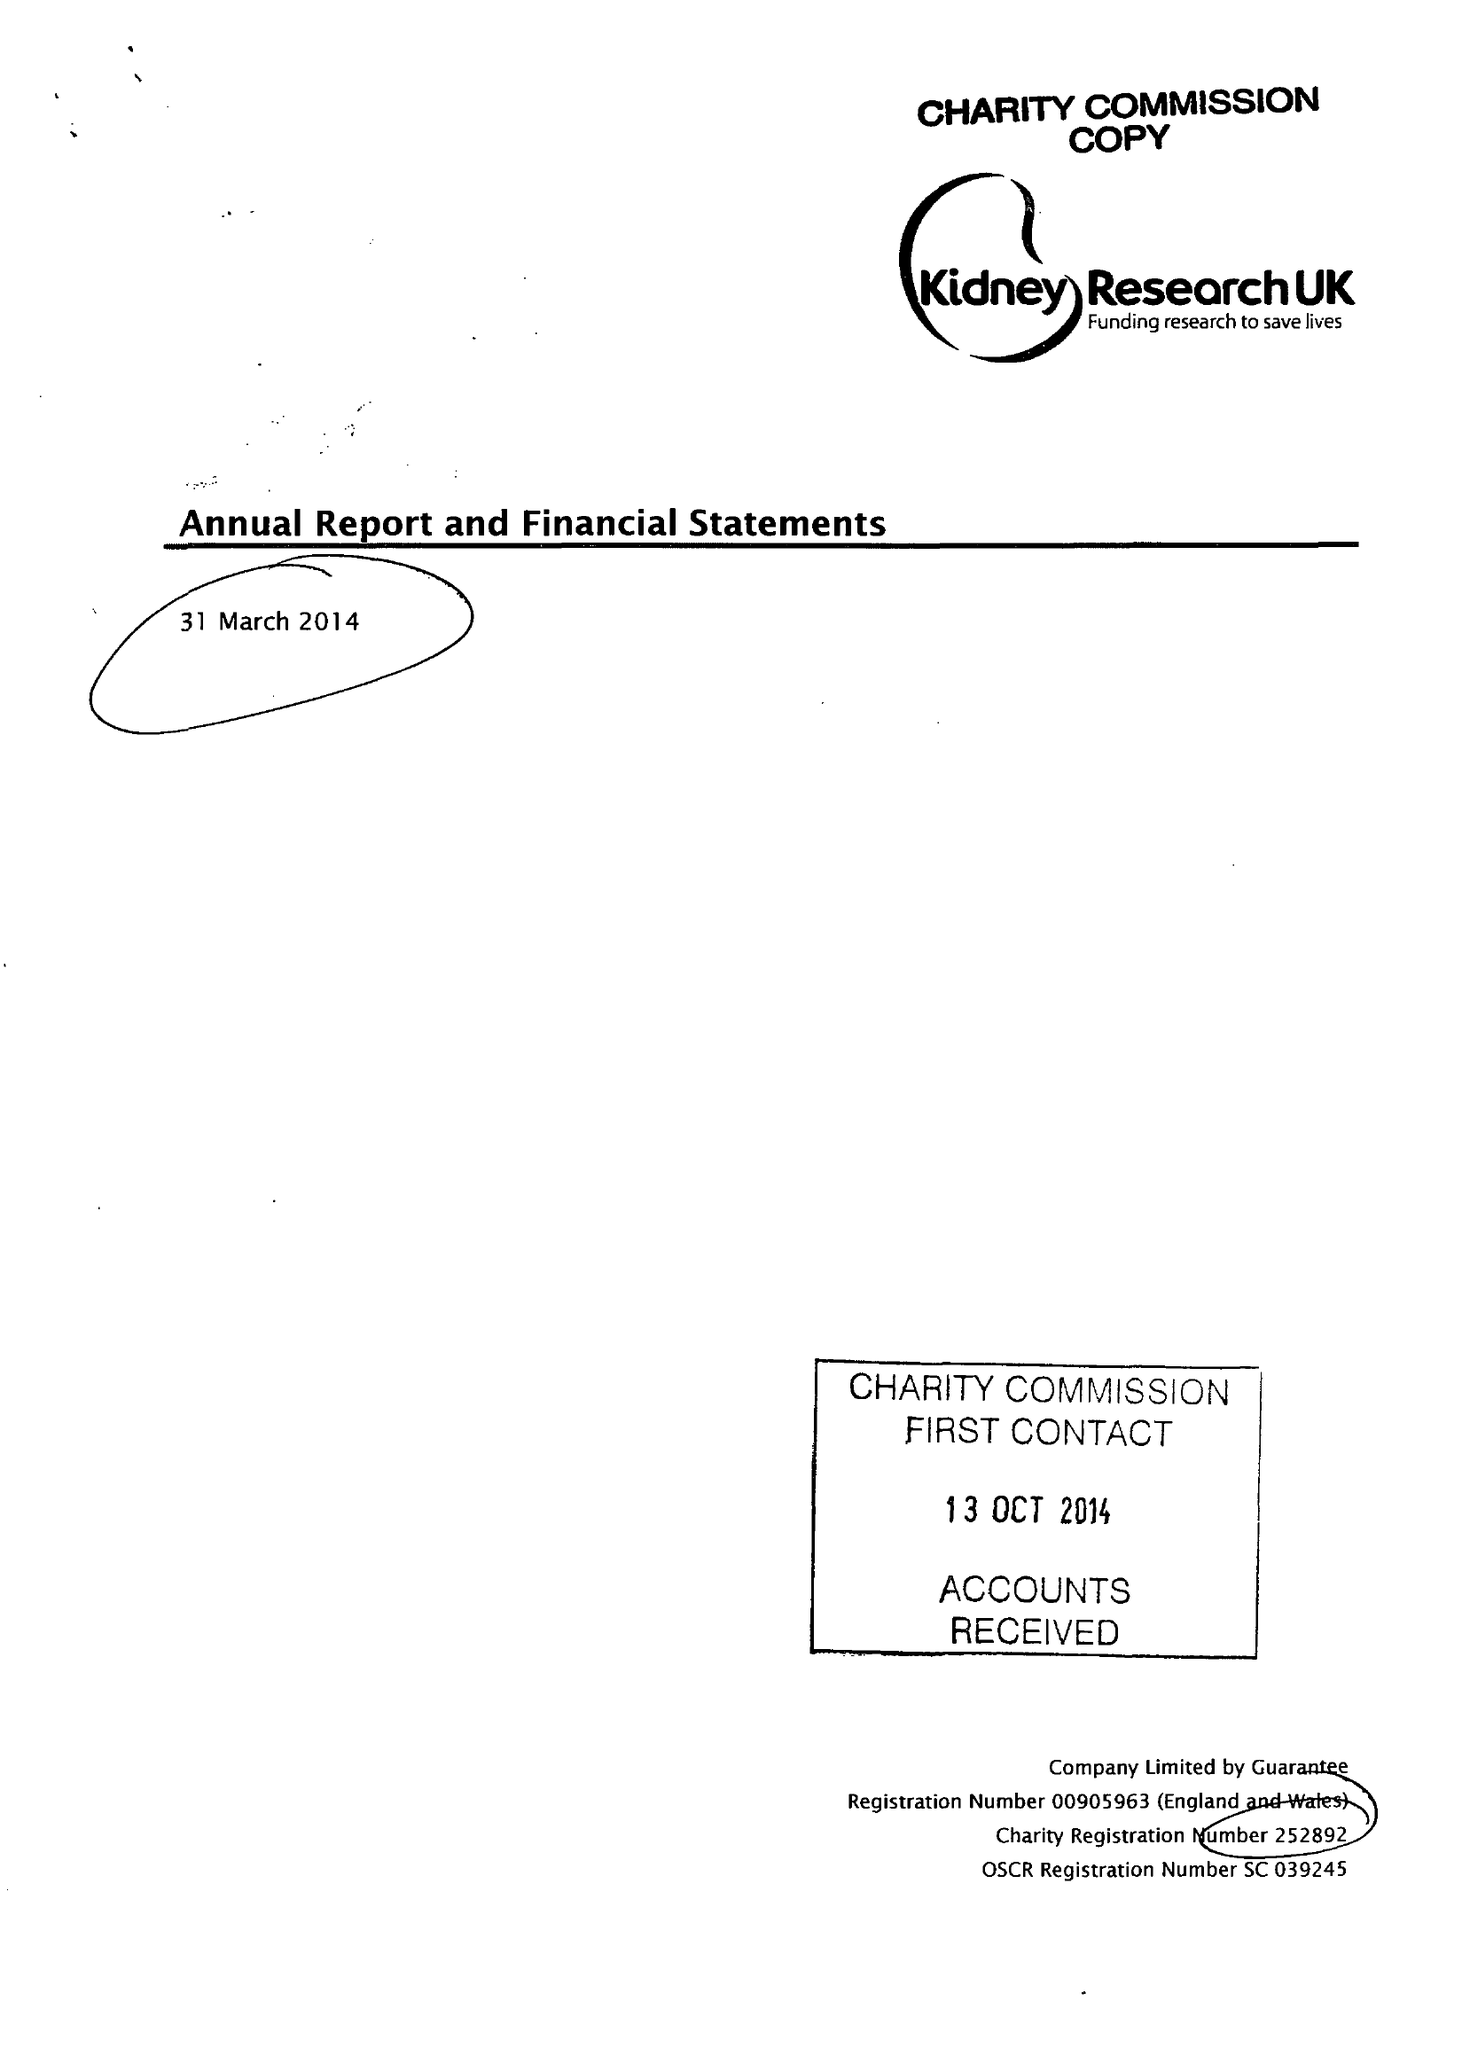What is the value for the address__street_line?
Answer the question using a single word or phrase. None 